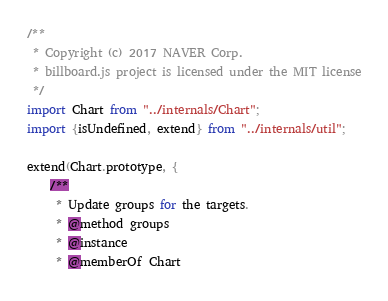<code> <loc_0><loc_0><loc_500><loc_500><_JavaScript_>/**
 * Copyright (c) 2017 NAVER Corp.
 * billboard.js project is licensed under the MIT license
 */
import Chart from "../internals/Chart";
import {isUndefined, extend} from "../internals/util";

extend(Chart.prototype, {
	/**
	 * Update groups for the targets.
	 * @method groups
	 * @instance
	 * @memberOf Chart</code> 